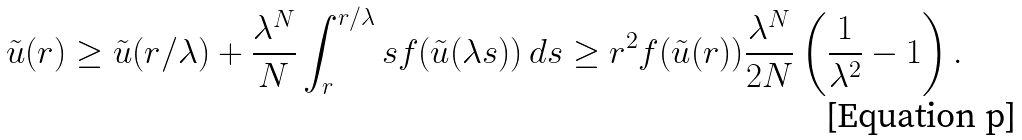Convert formula to latex. <formula><loc_0><loc_0><loc_500><loc_500>\tilde { u } ( r ) \geq \tilde { u } ( r / \lambda ) + \frac { \lambda ^ { N } } { N } \int _ { r } ^ { r / \lambda } s f ( \tilde { u } ( \lambda s ) ) \, d s \geq r ^ { 2 } f ( \tilde { u } ( r ) ) \frac { \lambda ^ { N } } { 2 N } \left ( \frac { 1 } { \lambda ^ { 2 } } - 1 \right ) .</formula> 